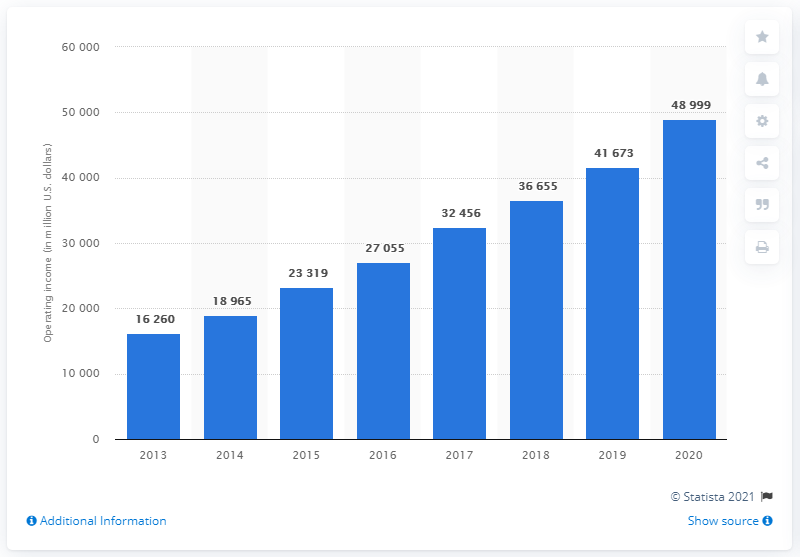Point out several critical features in this image. In 2020, Google's operating income was approximately 48,999 dollars. 